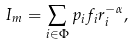<formula> <loc_0><loc_0><loc_500><loc_500>I _ { m } = \sum _ { i \in \Phi } p _ { i } f _ { i } r ^ { - \alpha } _ { i } ,</formula> 